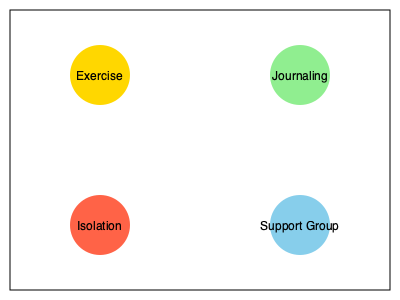As a therapist specializing in post-adoption support for birth mothers, which two activities from the illustrated set would you most likely recommend as healthy coping mechanisms? 1. Exercise (top-left): Physical activity is known to release endorphins, reduce stress, and improve overall mental health. It's a positive way to manage emotions and maintain well-being.

2. Journaling (top-right): Writing about one's feelings and experiences can help process emotions, gain clarity, and track personal growth. It's a therapeutic tool often recommended by mental health professionals.

3. Isolation (bottom-left): While some alone time can be beneficial, prolonged isolation is generally not considered a healthy coping mechanism. It can lead to increased feelings of loneliness and depression, which may exacerbate emotional struggles.

4. Support Group (bottom-right): Participating in a support group allows birth mothers to connect with others who have similar experiences, share their feelings, and receive emotional support. It can reduce feelings of isolation and provide valuable coping strategies.

Based on this analysis, the two most appropriate activities for healthy coping are Exercise and Journaling. These activities promote physical and emotional well-being without the potential negative effects of isolation. While a Support Group is also beneficial, the question asks for the two most likely recommendations, and Exercise and Journaling are more versatile and can be practiced independently.
Answer: Exercise and Journaling 